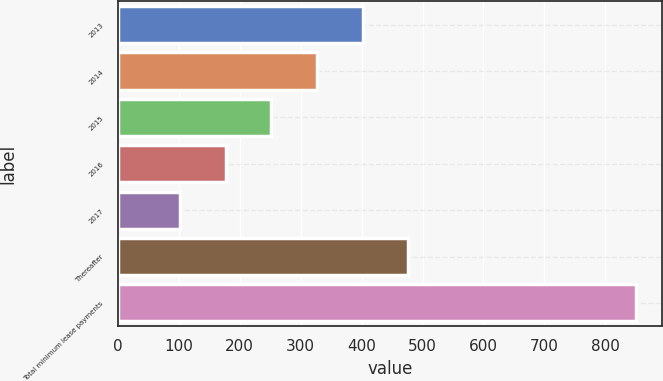Convert chart to OTSL. <chart><loc_0><loc_0><loc_500><loc_500><bar_chart><fcel>2013<fcel>2014<fcel>2015<fcel>2016<fcel>2017<fcel>Thereafter<fcel>Total minimum lease payments<nl><fcel>401.6<fcel>326.7<fcel>251.8<fcel>176.9<fcel>102<fcel>476.5<fcel>851<nl></chart> 